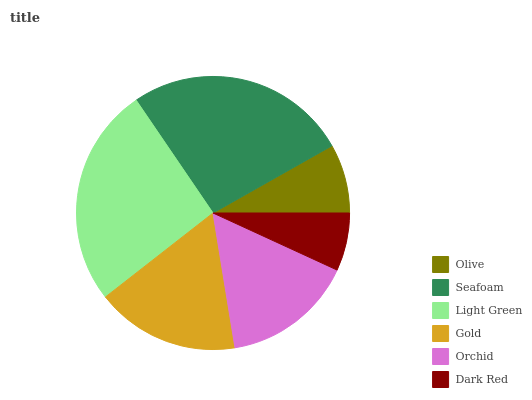Is Dark Red the minimum?
Answer yes or no. Yes. Is Seafoam the maximum?
Answer yes or no. Yes. Is Light Green the minimum?
Answer yes or no. No. Is Light Green the maximum?
Answer yes or no. No. Is Seafoam greater than Light Green?
Answer yes or no. Yes. Is Light Green less than Seafoam?
Answer yes or no. Yes. Is Light Green greater than Seafoam?
Answer yes or no. No. Is Seafoam less than Light Green?
Answer yes or no. No. Is Gold the high median?
Answer yes or no. Yes. Is Orchid the low median?
Answer yes or no. Yes. Is Light Green the high median?
Answer yes or no. No. Is Dark Red the low median?
Answer yes or no. No. 